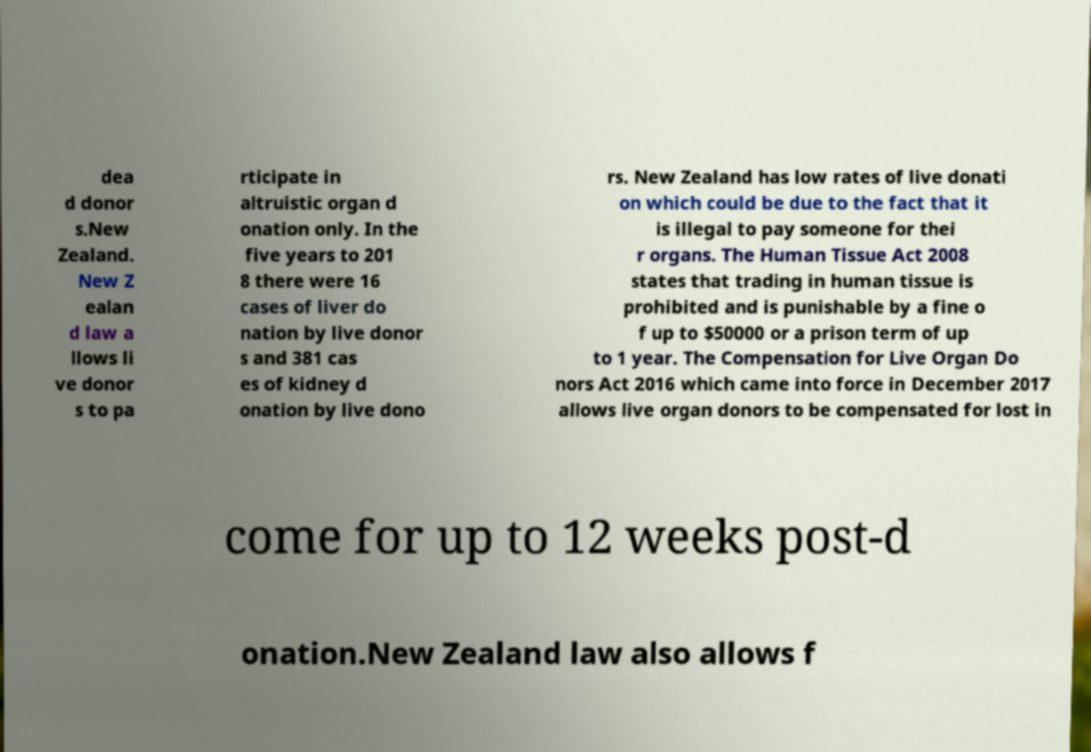Can you read and provide the text displayed in the image?This photo seems to have some interesting text. Can you extract and type it out for me? dea d donor s.New Zealand. New Z ealan d law a llows li ve donor s to pa rticipate in altruistic organ d onation only. In the five years to 201 8 there were 16 cases of liver do nation by live donor s and 381 cas es of kidney d onation by live dono rs. New Zealand has low rates of live donati on which could be due to the fact that it is illegal to pay someone for thei r organs. The Human Tissue Act 2008 states that trading in human tissue is prohibited and is punishable by a fine o f up to $50000 or a prison term of up to 1 year. The Compensation for Live Organ Do nors Act 2016 which came into force in December 2017 allows live organ donors to be compensated for lost in come for up to 12 weeks post-d onation.New Zealand law also allows f 